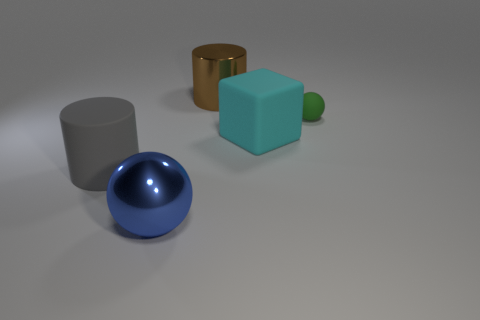Are there any other things that have the same material as the tiny thing?
Your answer should be compact. Yes. Does the gray rubber cylinder have the same size as the sphere behind the blue thing?
Your response must be concise. No. What is the material of the ball that is in front of the large rubber object that is on the right side of the large gray rubber thing?
Ensure brevity in your answer.  Metal. Are there the same number of rubber spheres on the left side of the big blue metal thing and purple objects?
Your answer should be compact. Yes. There is a object that is both on the left side of the big cyan cube and behind the cyan matte cube; what size is it?
Offer a terse response. Large. The large cylinder in front of the cylinder that is behind the small sphere is what color?
Your answer should be very brief. Gray. Are there the same number of tiny rubber objects and green cubes?
Provide a succinct answer. No. How many cyan things are small balls or big rubber things?
Keep it short and to the point. 1. What is the color of the matte thing that is on the right side of the big gray rubber object and in front of the green thing?
Your answer should be very brief. Cyan. How many large things are either cylinders or cyan things?
Make the answer very short. 3. 